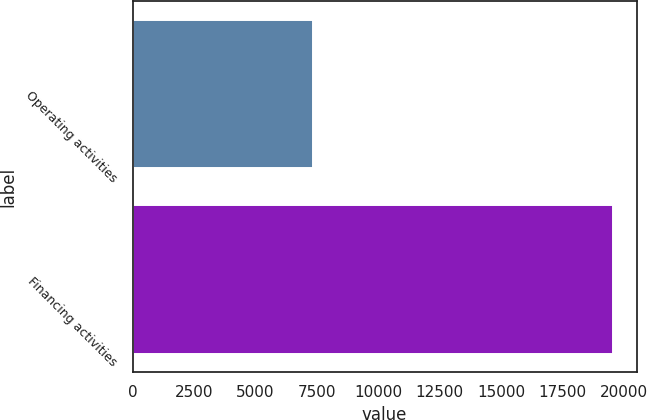Convert chart to OTSL. <chart><loc_0><loc_0><loc_500><loc_500><bar_chart><fcel>Operating activities<fcel>Financing activities<nl><fcel>7326<fcel>19540<nl></chart> 